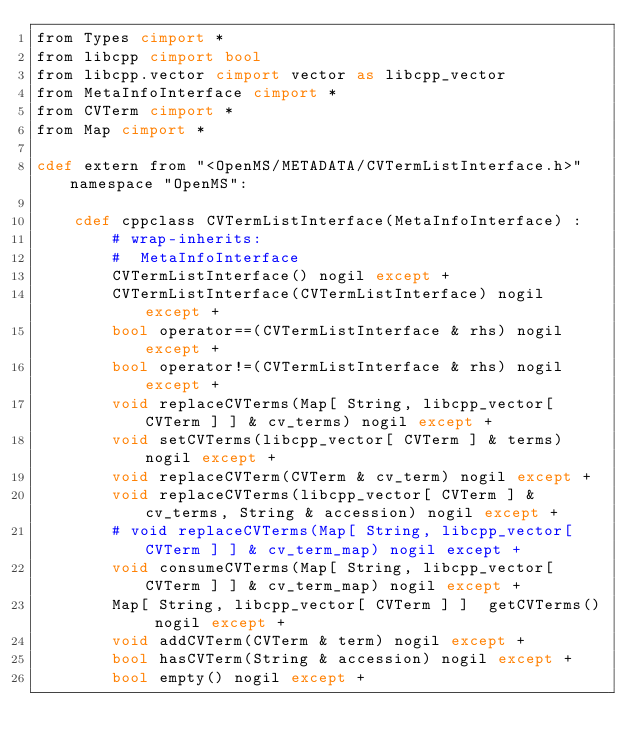Convert code to text. <code><loc_0><loc_0><loc_500><loc_500><_Cython_>from Types cimport *
from libcpp cimport bool
from libcpp.vector cimport vector as libcpp_vector
from MetaInfoInterface cimport *
from CVTerm cimport *
from Map cimport *

cdef extern from "<OpenMS/METADATA/CVTermListInterface.h>" namespace "OpenMS":
    
    cdef cppclass CVTermListInterface(MetaInfoInterface) :
        # wrap-inherits:
        #  MetaInfoInterface
        CVTermListInterface() nogil except +
        CVTermListInterface(CVTermListInterface) nogil except +
        bool operator==(CVTermListInterface & rhs) nogil except +
        bool operator!=(CVTermListInterface & rhs) nogil except +
        void replaceCVTerms(Map[ String, libcpp_vector[ CVTerm ] ] & cv_terms) nogil except +
        void setCVTerms(libcpp_vector[ CVTerm ] & terms) nogil except +
        void replaceCVTerm(CVTerm & cv_term) nogil except +
        void replaceCVTerms(libcpp_vector[ CVTerm ] & cv_terms, String & accession) nogil except +
        # void replaceCVTerms(Map[ String, libcpp_vector[ CVTerm ] ] & cv_term_map) nogil except +
        void consumeCVTerms(Map[ String, libcpp_vector[ CVTerm ] ] & cv_term_map) nogil except +
        Map[ String, libcpp_vector[ CVTerm ] ]  getCVTerms() nogil except +
        void addCVTerm(CVTerm & term) nogil except +
        bool hasCVTerm(String & accession) nogil except +
        bool empty() nogil except +

</code> 